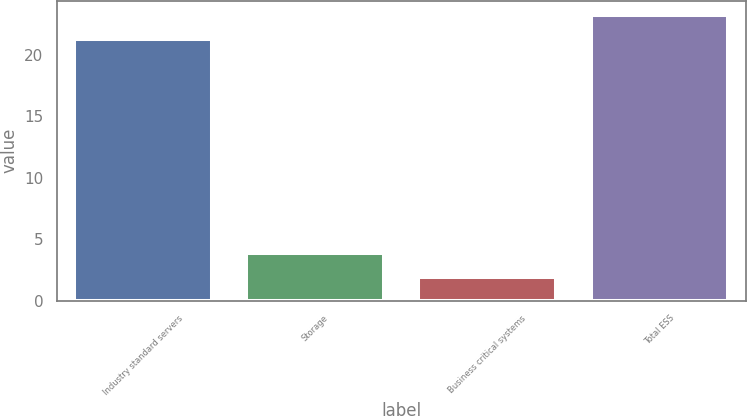<chart> <loc_0><loc_0><loc_500><loc_500><bar_chart><fcel>Industry standard servers<fcel>Storage<fcel>Business critical systems<fcel>Total ESS<nl><fcel>21.3<fcel>3.85<fcel>1.9<fcel>23.25<nl></chart> 